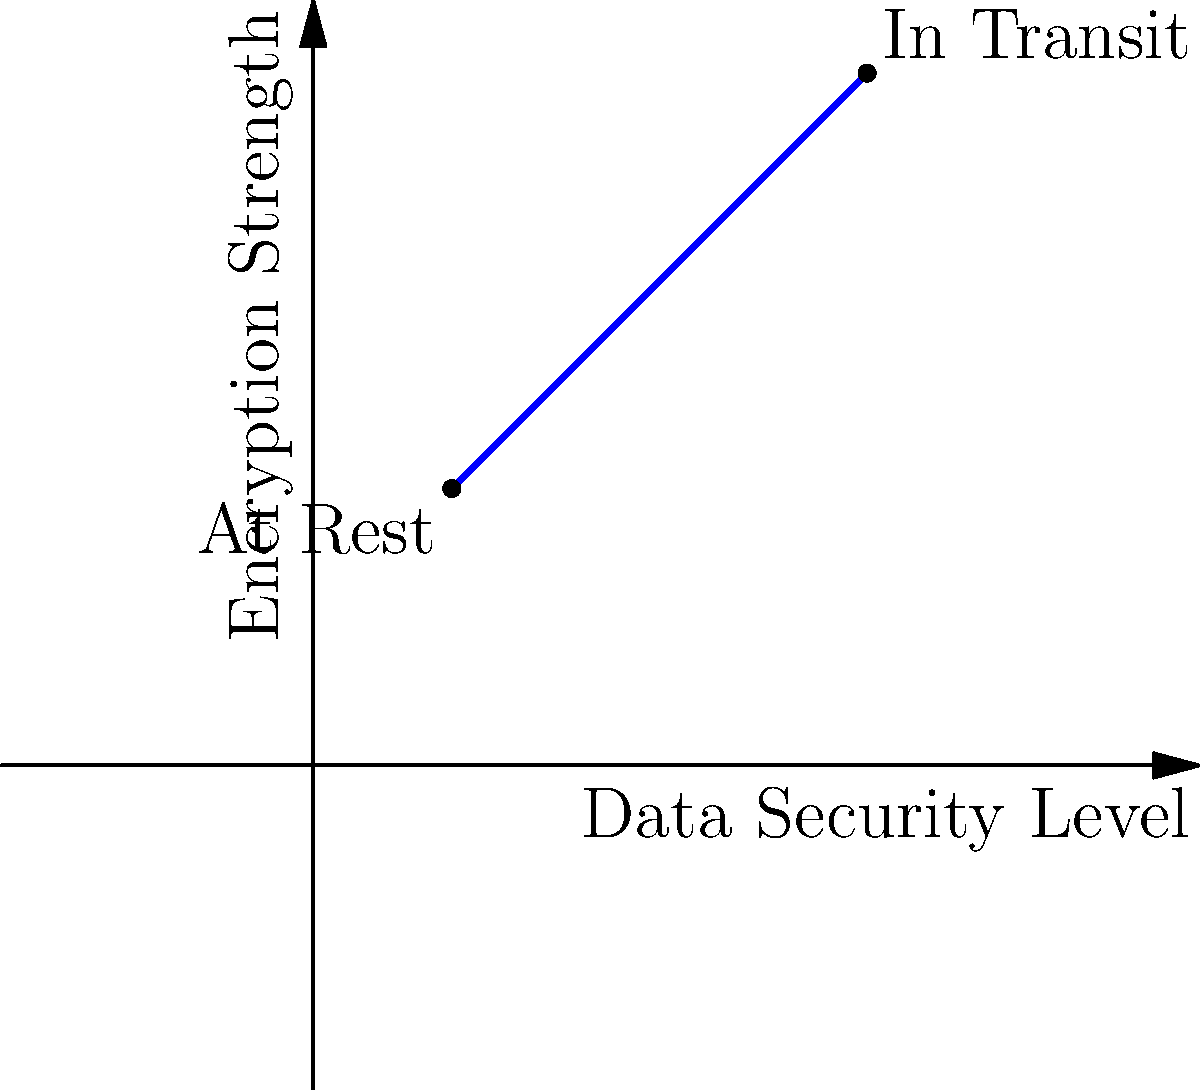Based on the graph depicting the relationship between Data Security Level and Encryption Strength, which encryption method would be most suitable for protecting customer information both at rest and in transit? To determine the most suitable encryption method for protecting customer information both at rest and in transit, let's analyze the graph step-by-step:

1. The x-axis represents the Data Security Level, while the y-axis represents the Encryption Strength.
2. The graph shows a positive correlation between Data Security Level and Encryption Strength.
3. Two points are highlighted on the graph:
   a. "At Rest" (1,2): Lower Data Security Level and lower Encryption Strength
   b. "In Transit" (4,5): Higher Data Security Level and higher Encryption Strength
4. For optimal protection, we need an encryption method that can handle both scenarios effectively.
5. The ideal solution should provide high encryption strength for both at-rest and in-transit data.
6. Advanced Encryption Standard (AES) with a 256-bit key length (AES-256) is widely recognized as a secure encryption method for both at-rest and in-transit data.
7. AES-256 offers:
   a. Strong encryption for data at rest (e.g., stored in databases)
   b. Robust security for data in transit (e.g., over networks)
   c. Compliance with various regulatory requirements in the banking sector

Given these considerations, AES-256 would be the most suitable encryption method for protecting customer information both at rest and in transit, as it provides high encryption strength across various data security levels.
Answer: AES-256 